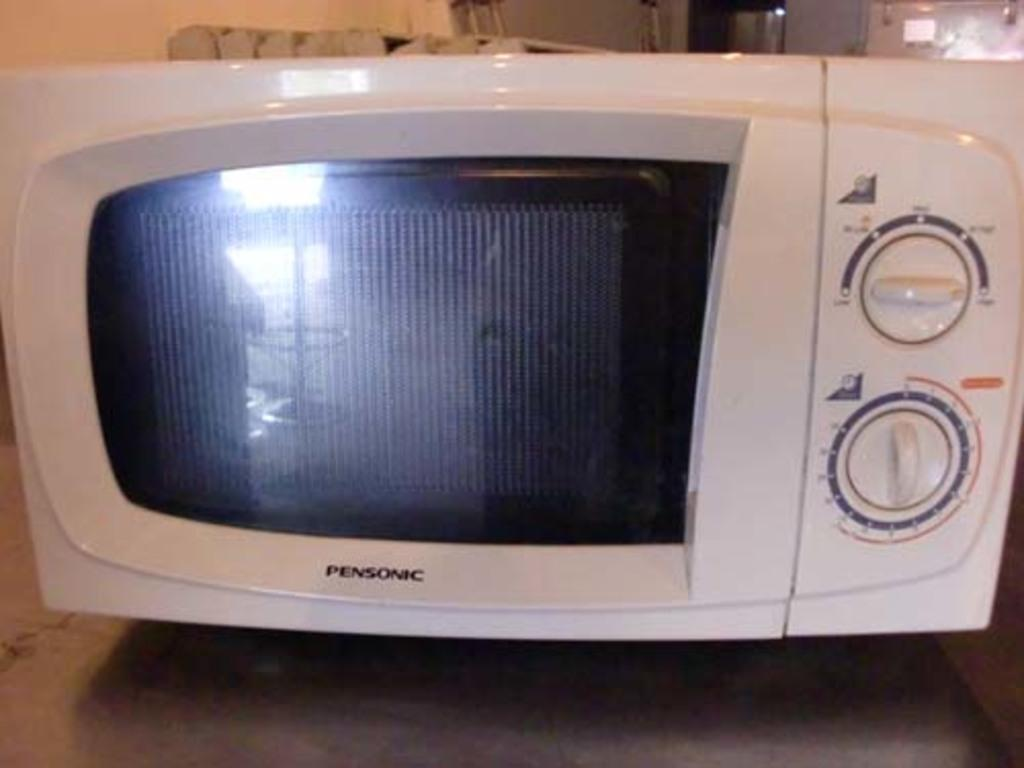<image>
Give a short and clear explanation of the subsequent image. A white pensonic microwave with two dials on it 